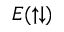Convert formula to latex. <formula><loc_0><loc_0><loc_500><loc_500>E ( \uparrow \downarrow )</formula> 